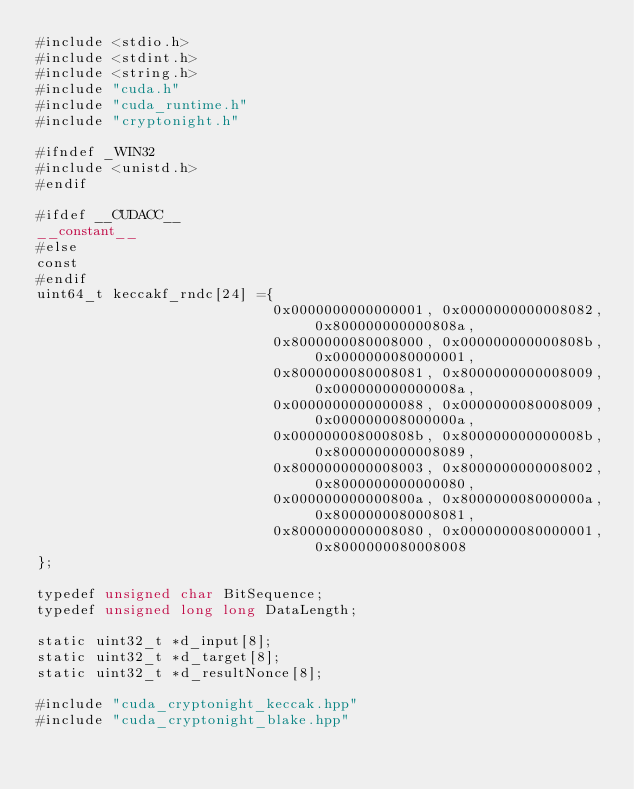Convert code to text. <code><loc_0><loc_0><loc_500><loc_500><_Cuda_>#include <stdio.h>
#include <stdint.h>
#include <string.h>
#include "cuda.h"
#include "cuda_runtime.h"
#include "cryptonight.h"

#ifndef _WIN32
#include <unistd.h>
#endif

#ifdef __CUDACC__
__constant__
#else
const
#endif
uint64_t keccakf_rndc[24] ={
                            0x0000000000000001, 0x0000000000008082, 0x800000000000808a,
                            0x8000000080008000, 0x000000000000808b, 0x0000000080000001,
                            0x8000000080008081, 0x8000000000008009, 0x000000000000008a,
                            0x0000000000000088, 0x0000000080008009, 0x000000008000000a,
                            0x000000008000808b, 0x800000000000008b, 0x8000000000008089,
                            0x8000000000008003, 0x8000000000008002, 0x8000000000000080,
                            0x000000000000800a, 0x800000008000000a, 0x8000000080008081,
                            0x8000000000008080, 0x0000000080000001, 0x8000000080008008
};

typedef unsigned char BitSequence;
typedef unsigned long long DataLength;

static uint32_t *d_input[8];
static uint32_t *d_target[8];
static uint32_t *d_resultNonce[8];

#include "cuda_cryptonight_keccak.hpp"
#include "cuda_cryptonight_blake.hpp"</code> 